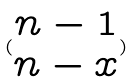Convert formula to latex. <formula><loc_0><loc_0><loc_500><loc_500>( \begin{matrix} n - 1 \\ n - x \end{matrix} )</formula> 